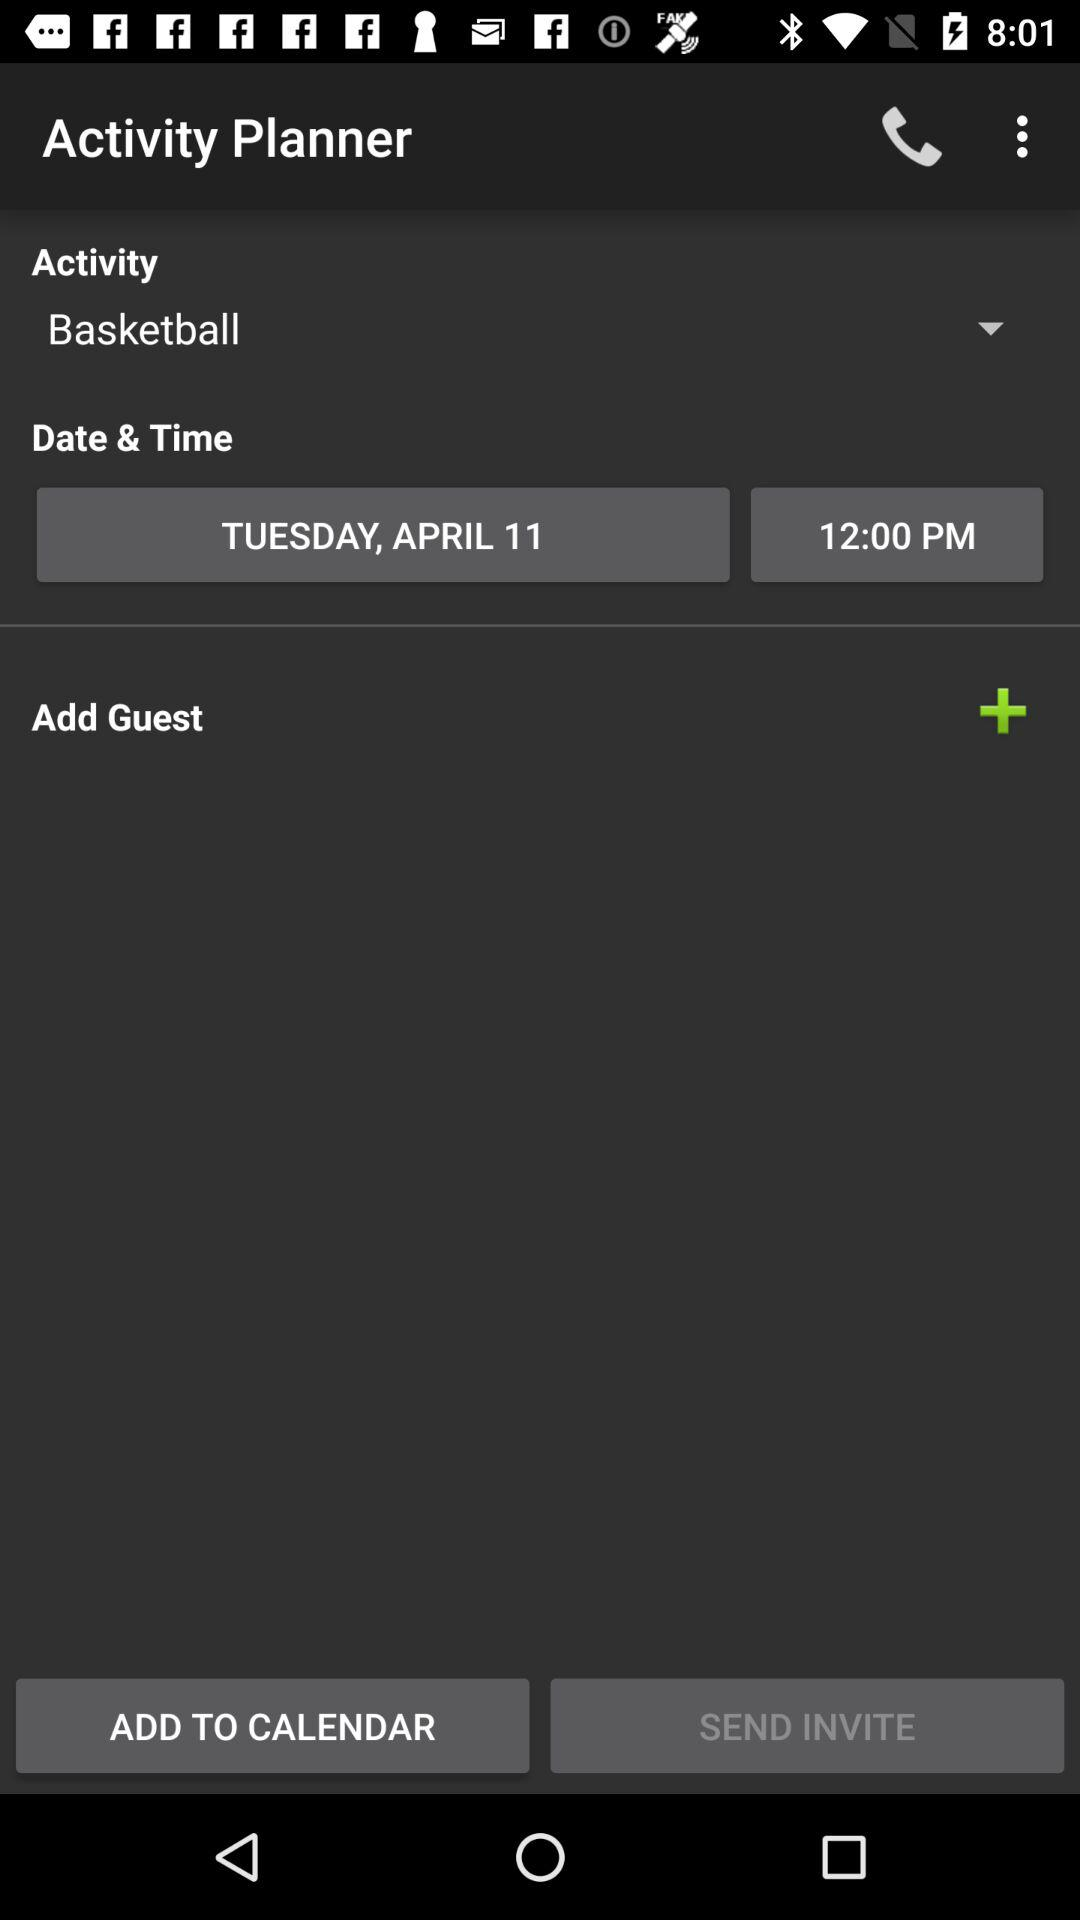What option is selected for "Activity"? The selected option for "Activity" is "Basketball". 